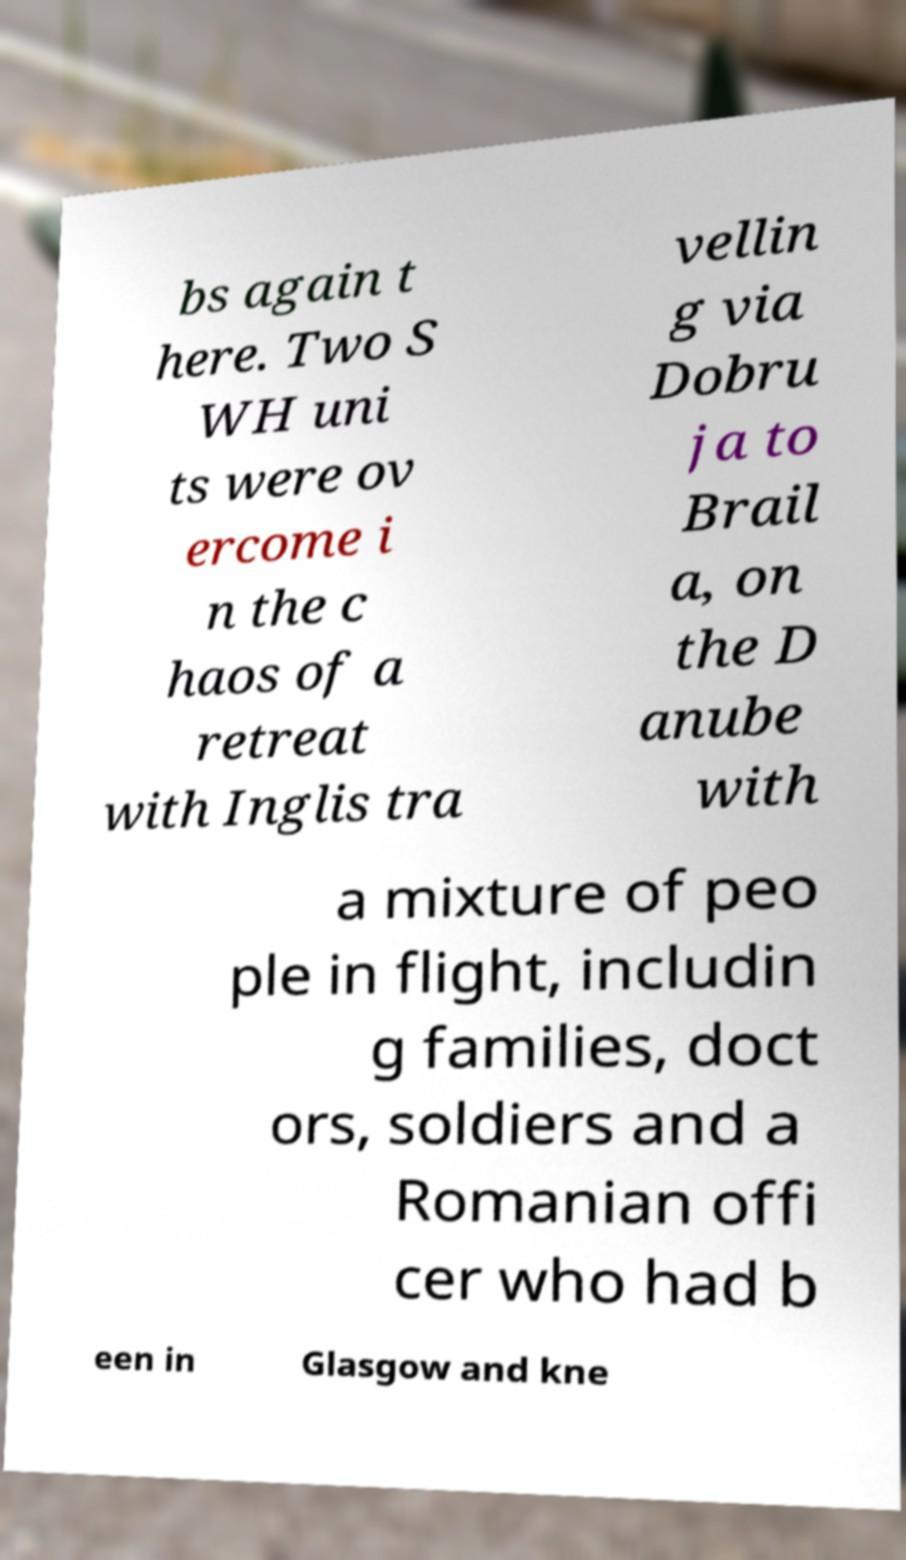Can you read and provide the text displayed in the image?This photo seems to have some interesting text. Can you extract and type it out for me? bs again t here. Two S WH uni ts were ov ercome i n the c haos of a retreat with Inglis tra vellin g via Dobru ja to Brail a, on the D anube with a mixture of peo ple in flight, includin g families, doct ors, soldiers and a Romanian offi cer who had b een in Glasgow and kne 